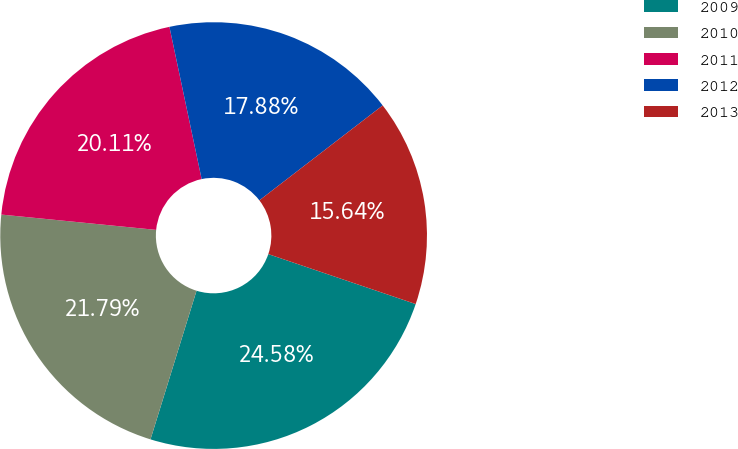Convert chart to OTSL. <chart><loc_0><loc_0><loc_500><loc_500><pie_chart><fcel>2009<fcel>2010<fcel>2011<fcel>2012<fcel>2013<nl><fcel>24.58%<fcel>21.79%<fcel>20.11%<fcel>17.88%<fcel>15.64%<nl></chart> 